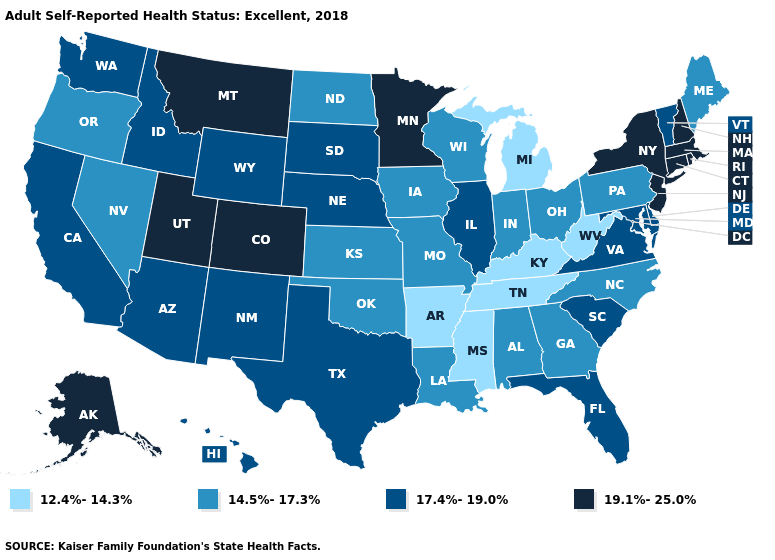Which states hav the highest value in the Northeast?
Short answer required. Connecticut, Massachusetts, New Hampshire, New Jersey, New York, Rhode Island. Does Texas have the highest value in the USA?
Be succinct. No. What is the value of New Jersey?
Short answer required. 19.1%-25.0%. What is the value of Hawaii?
Quick response, please. 17.4%-19.0%. Name the states that have a value in the range 14.5%-17.3%?
Keep it brief. Alabama, Georgia, Indiana, Iowa, Kansas, Louisiana, Maine, Missouri, Nevada, North Carolina, North Dakota, Ohio, Oklahoma, Oregon, Pennsylvania, Wisconsin. Name the states that have a value in the range 12.4%-14.3%?
Write a very short answer. Arkansas, Kentucky, Michigan, Mississippi, Tennessee, West Virginia. Does Oregon have the lowest value in the USA?
Keep it brief. No. Among the states that border Oklahoma , does Colorado have the highest value?
Concise answer only. Yes. Name the states that have a value in the range 12.4%-14.3%?
Concise answer only. Arkansas, Kentucky, Michigan, Mississippi, Tennessee, West Virginia. Which states have the lowest value in the Northeast?
Be succinct. Maine, Pennsylvania. Does Pennsylvania have the highest value in the Northeast?
Be succinct. No. Among the states that border New Jersey , does Delaware have the highest value?
Quick response, please. No. Does South Carolina have the highest value in the South?
Short answer required. Yes. Which states have the highest value in the USA?
Answer briefly. Alaska, Colorado, Connecticut, Massachusetts, Minnesota, Montana, New Hampshire, New Jersey, New York, Rhode Island, Utah. How many symbols are there in the legend?
Quick response, please. 4. 